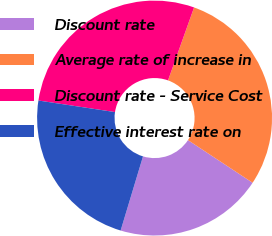Convert chart to OTSL. <chart><loc_0><loc_0><loc_500><loc_500><pie_chart><fcel>Discount rate<fcel>Average rate of increase in<fcel>Discount rate - Service Cost<fcel>Effective interest rate on<nl><fcel>20.38%<fcel>28.82%<fcel>28.07%<fcel>22.72%<nl></chart> 